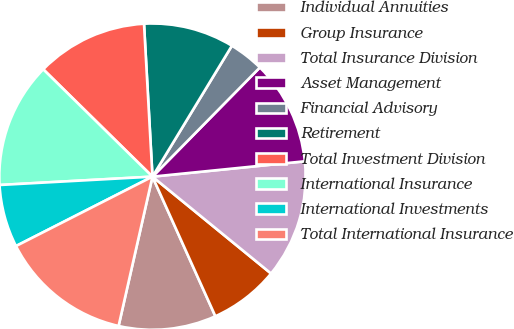<chart> <loc_0><loc_0><loc_500><loc_500><pie_chart><fcel>Individual Annuities<fcel>Group Insurance<fcel>Total Insurance Division<fcel>Asset Management<fcel>Financial Advisory<fcel>Retirement<fcel>Total Investment Division<fcel>International Insurance<fcel>International Investments<fcel>Total International Insurance<nl><fcel>10.29%<fcel>7.36%<fcel>12.5%<fcel>11.03%<fcel>3.69%<fcel>9.56%<fcel>11.76%<fcel>13.23%<fcel>6.62%<fcel>13.96%<nl></chart> 